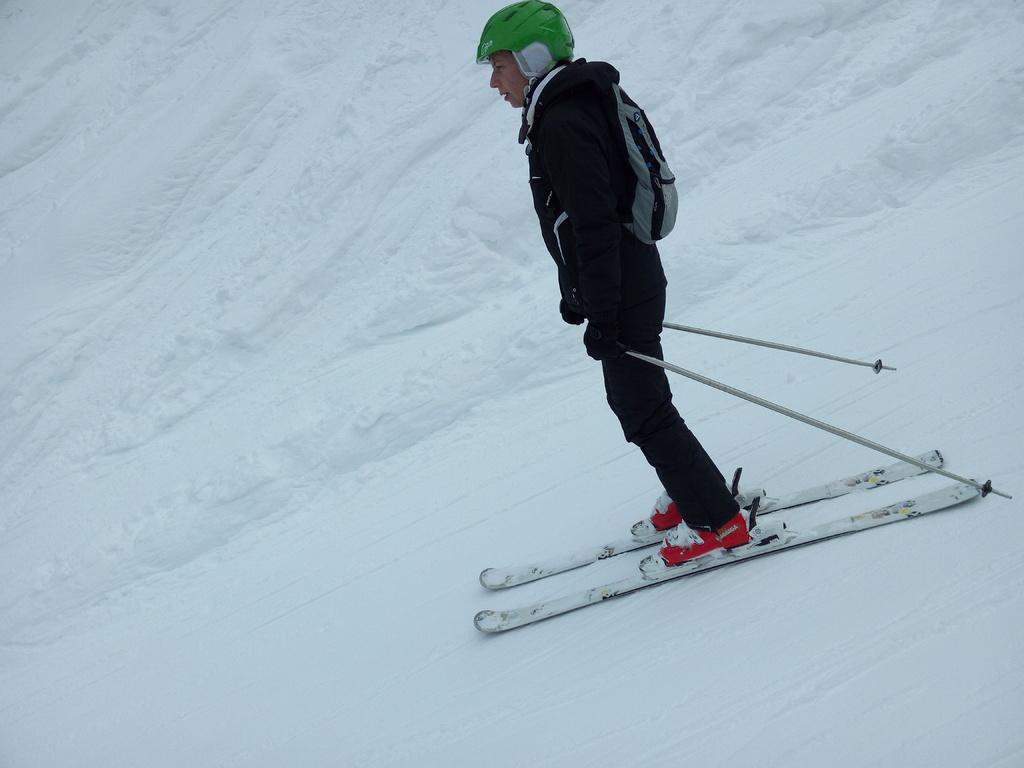Can you describe this image briefly? In the center of the image there is a person skiing on the snow. In the background we can see snow. 